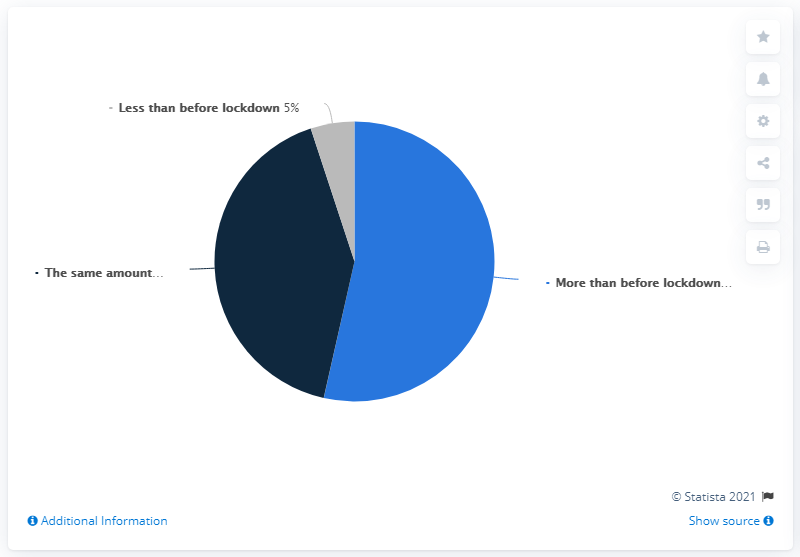Give some essential details in this illustration. The chart shows the sales figures of four different products before and after the lockdown. The option that is the least in the chart is the "Before lockdown" option, which is less than all the other options. The difference between the highest two values and the least one is 90. 